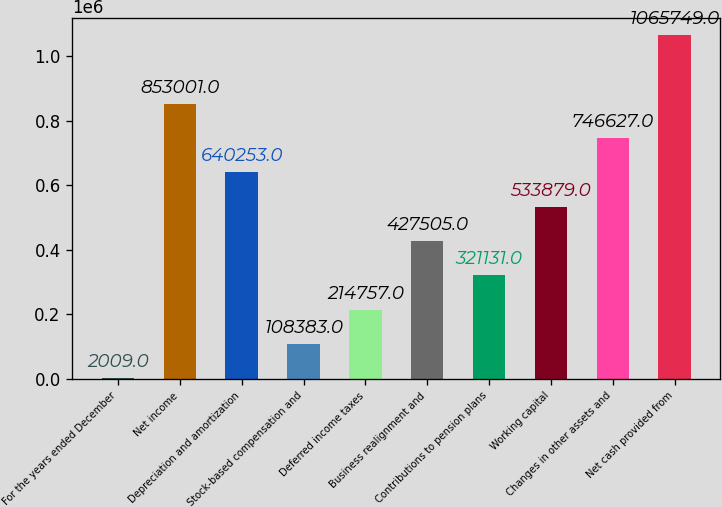Convert chart to OTSL. <chart><loc_0><loc_0><loc_500><loc_500><bar_chart><fcel>For the years ended December<fcel>Net income<fcel>Depreciation and amortization<fcel>Stock-based compensation and<fcel>Deferred income taxes<fcel>Business realignment and<fcel>Contributions to pension plans<fcel>Working capital<fcel>Changes in other assets and<fcel>Net cash provided from<nl><fcel>2009<fcel>853001<fcel>640253<fcel>108383<fcel>214757<fcel>427505<fcel>321131<fcel>533879<fcel>746627<fcel>1.06575e+06<nl></chart> 